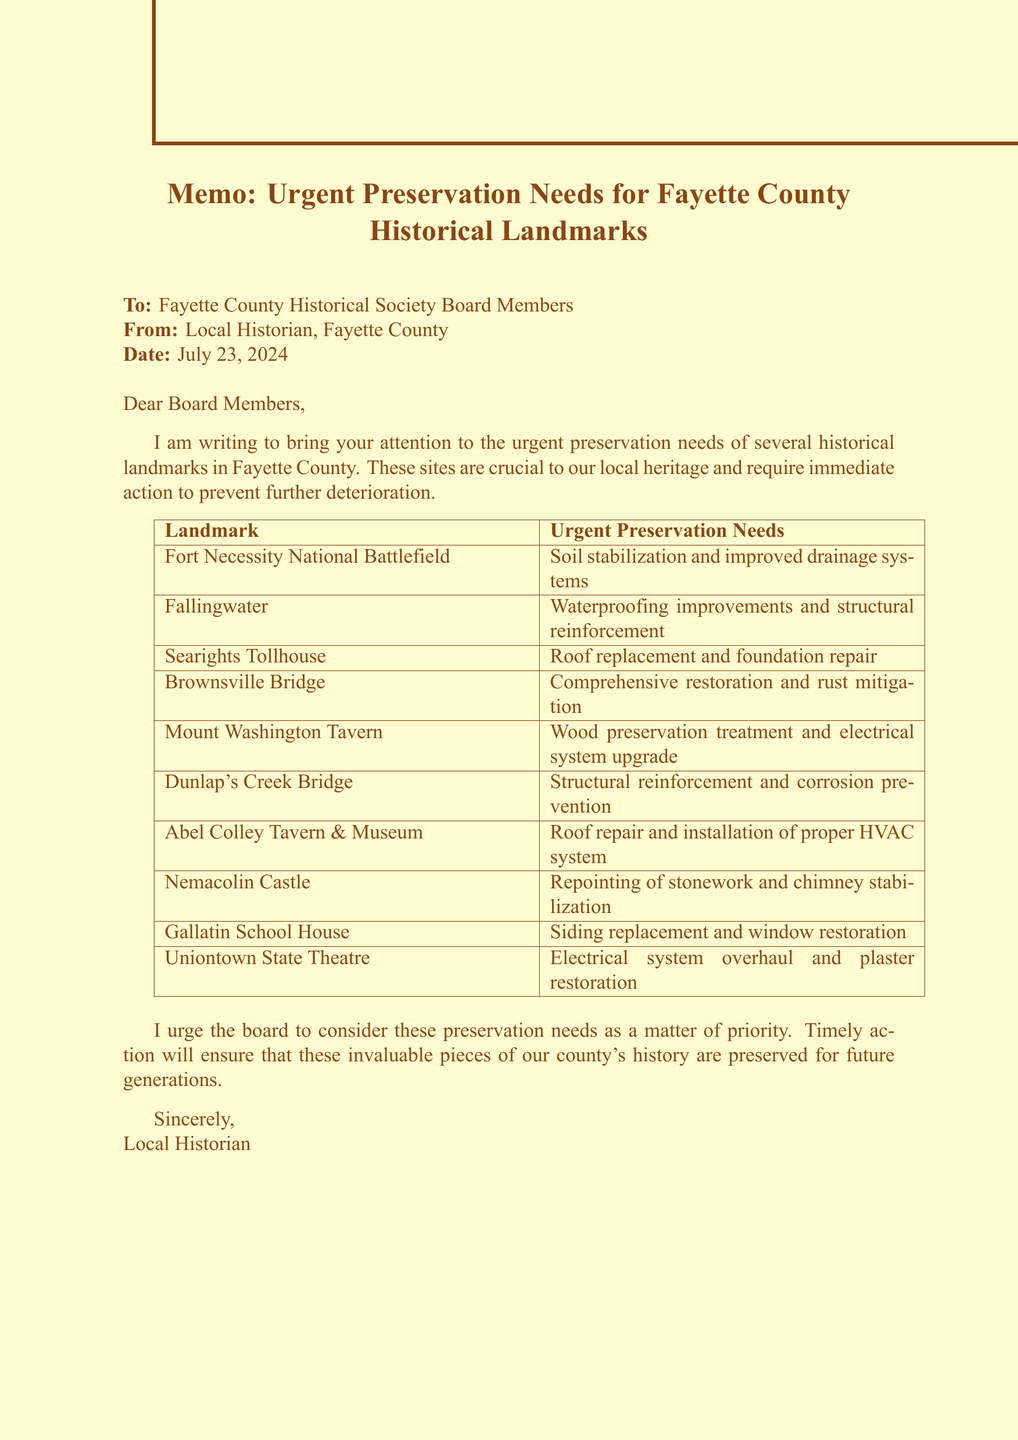what is the name of the first major battle site mentioned? The document lists "Fort Necessity National Battlefield" as the site of George Washington's first major battle in the French and Indian War.
Answer: Fort Necessity National Battlefield which landmark is a masterpiece of organic architecture? The document describes "Fallingwater" as an iconic house designed by Frank Lloyd Wright, recognized as a masterpiece of organic architecture.
Answer: Fallingwater what preservation needs are listed for the Brownsville Bridge? The document states that the Brownsville Bridge requires "comprehensive restoration and rust mitigation."
Answer: Comprehensive restoration and rust mitigation how many landmarks are urged for preservation in this memo? The document provides a list of ten historical landmarks in Fayette County that require urgent preservation efforts.
Answer: Ten which landmark has electrical system issues? The memo indicates that the "Uniontown State Theatre" has outdated electrical wiring that needs attention.
Answer: Uniontown State Theatre what year was the Dunlap's Creek Bridge built? The document lists the Dunlap's Creek Bridge as being built in 1839.
Answer: 1839 what is the main focus of this memo? The document focuses on the urgent preservation needs of several historical landmarks in Fayette County.
Answer: Urgent preservation needs which historical landmark is associated with the Whiskey Rebellion? The memo mentions "Nemacolin Castle" as being connected to the Whiskey Rebellion.
Answer: Nemacolin Castle what is the condition of the Searights Tollhouse? The document states that the Searights Tollhouse is in "deteriorating roof and foundation issues."
Answer: Deteriorating roof and foundation issues 